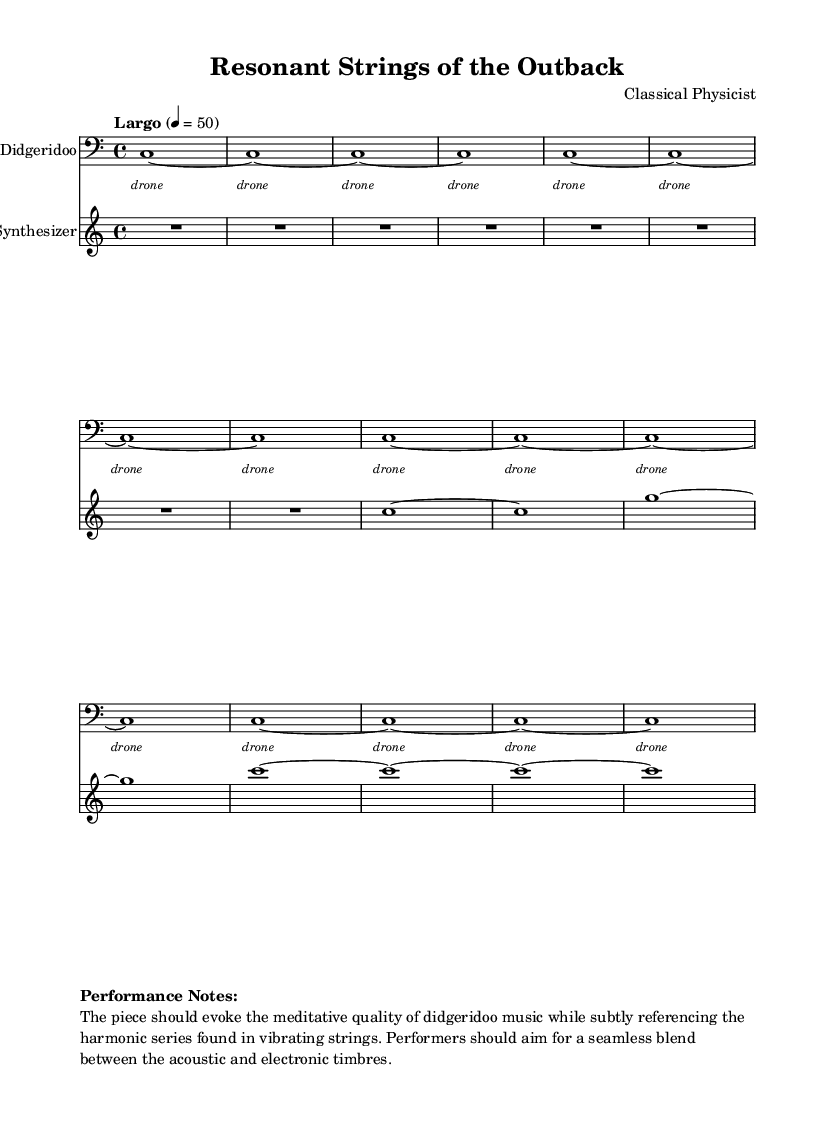What is the key signature of this music? The key signature is indicated in the global section with "c" for C major, which has no sharps or flats.
Answer: C major What is the time signature of this piece? The time signature is specified in the global section as "4/4," meaning there are four beats per measure and the quarter note gets one beat.
Answer: 4/4 What is the tempo marking of the music? The tempo marking is found in the global section as "Largo," indicating a slow pace, with a metronome marking of 50 beats per minute.
Answer: Largo How many instances of the word "drone" appear in the lyrics? The lyrics contain a repeat symbol with "16," meaning the word "drone" is repeated 16 times throughout the piece.
Answer: 16 What is the primary instrument used in this composition? The primary instrument is indicated at the beginning of the first staff as "Didgeridoo," highlighting the focus of this piece.
Answer: Didgeridoo How does the synthesizer relate to the didgeridoo in this piece? The synthesizer adds an electronic texture to the acoustic sound of the didgeridoo, meant to blend seamlessly and evoke harmony reminiscent of the harmonic series in vibrating strings.
Answer: Electronic texture What is the overall goal of the performance as noted in the performance notes? The performance notes encourage a focus on evoking a meditative quality while blending the acoustic and electronic elements, referencing the harmonic series found in vibrating strings.
Answer: Meditative quality 